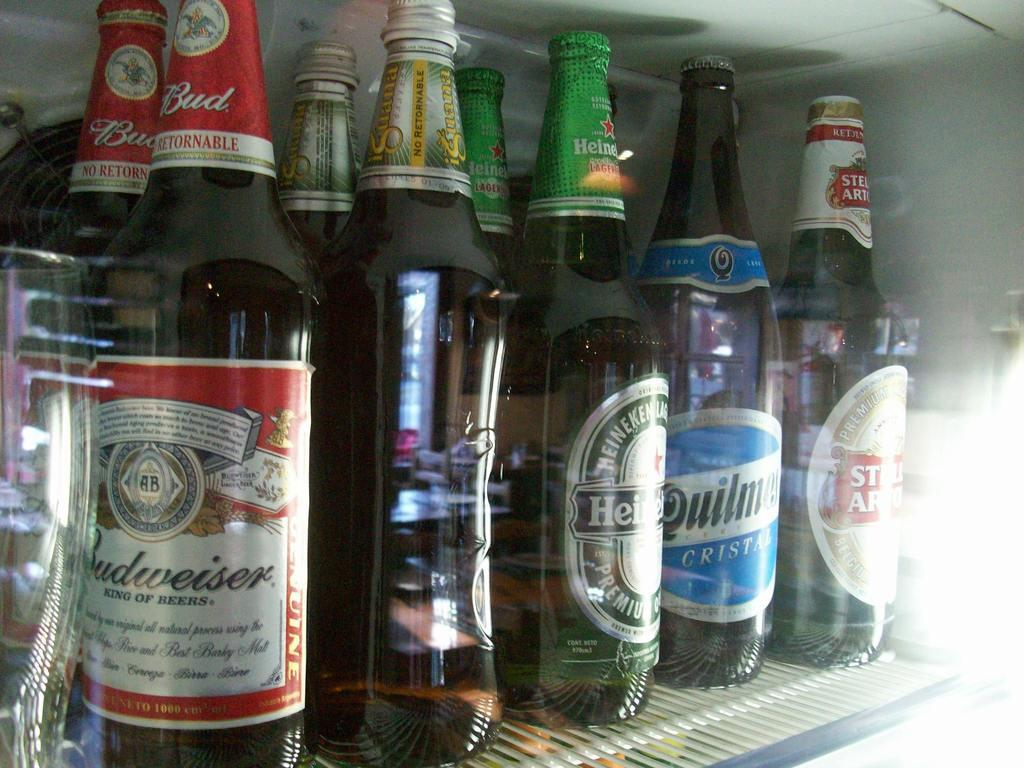<image>
Render a clear and concise summary of the photo. a row of beer bottles in the fridge with one of them labeled as budweiser 